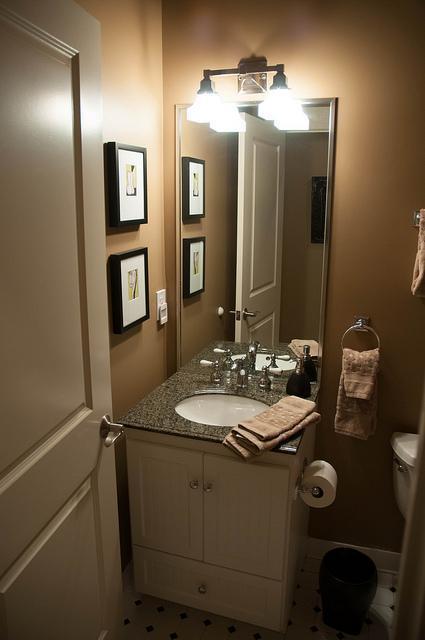How many people are in the image?
Give a very brief answer. 0. 